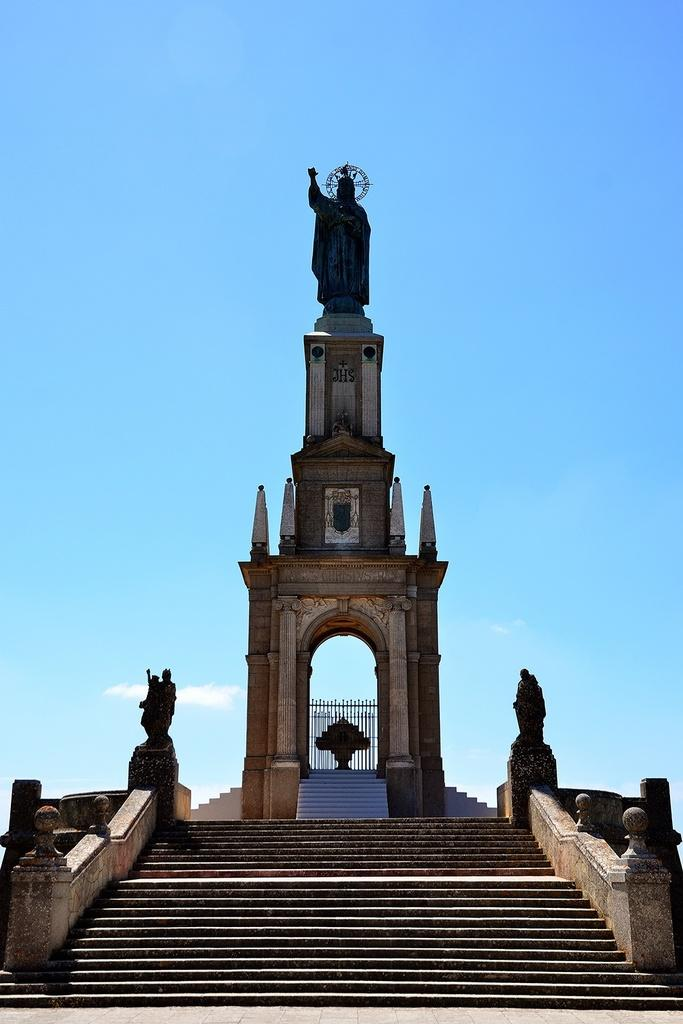What is the main structure in the center of the image? There is a tower in the center of the image. What is on top of the tower? There is a statue on the tower. How can someone access the tower? There are stairs at the bottom of the tower. What can be seen in the distance in the image? The sky is visible in the background of the image. How many teeth can be seen on the statue in the image? There are no teeth visible on the statue in the image. 